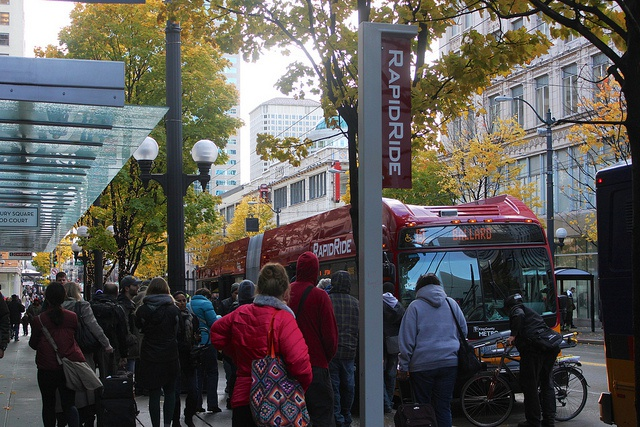Describe the objects in this image and their specific colors. I can see bus in darkgray, black, gray, maroon, and blue tones, people in darkgray, black, maroon, and brown tones, people in darkgray, black, and gray tones, people in darkgray, black, blue, gray, and navy tones, and people in darkgray, black, gray, and darkblue tones in this image. 